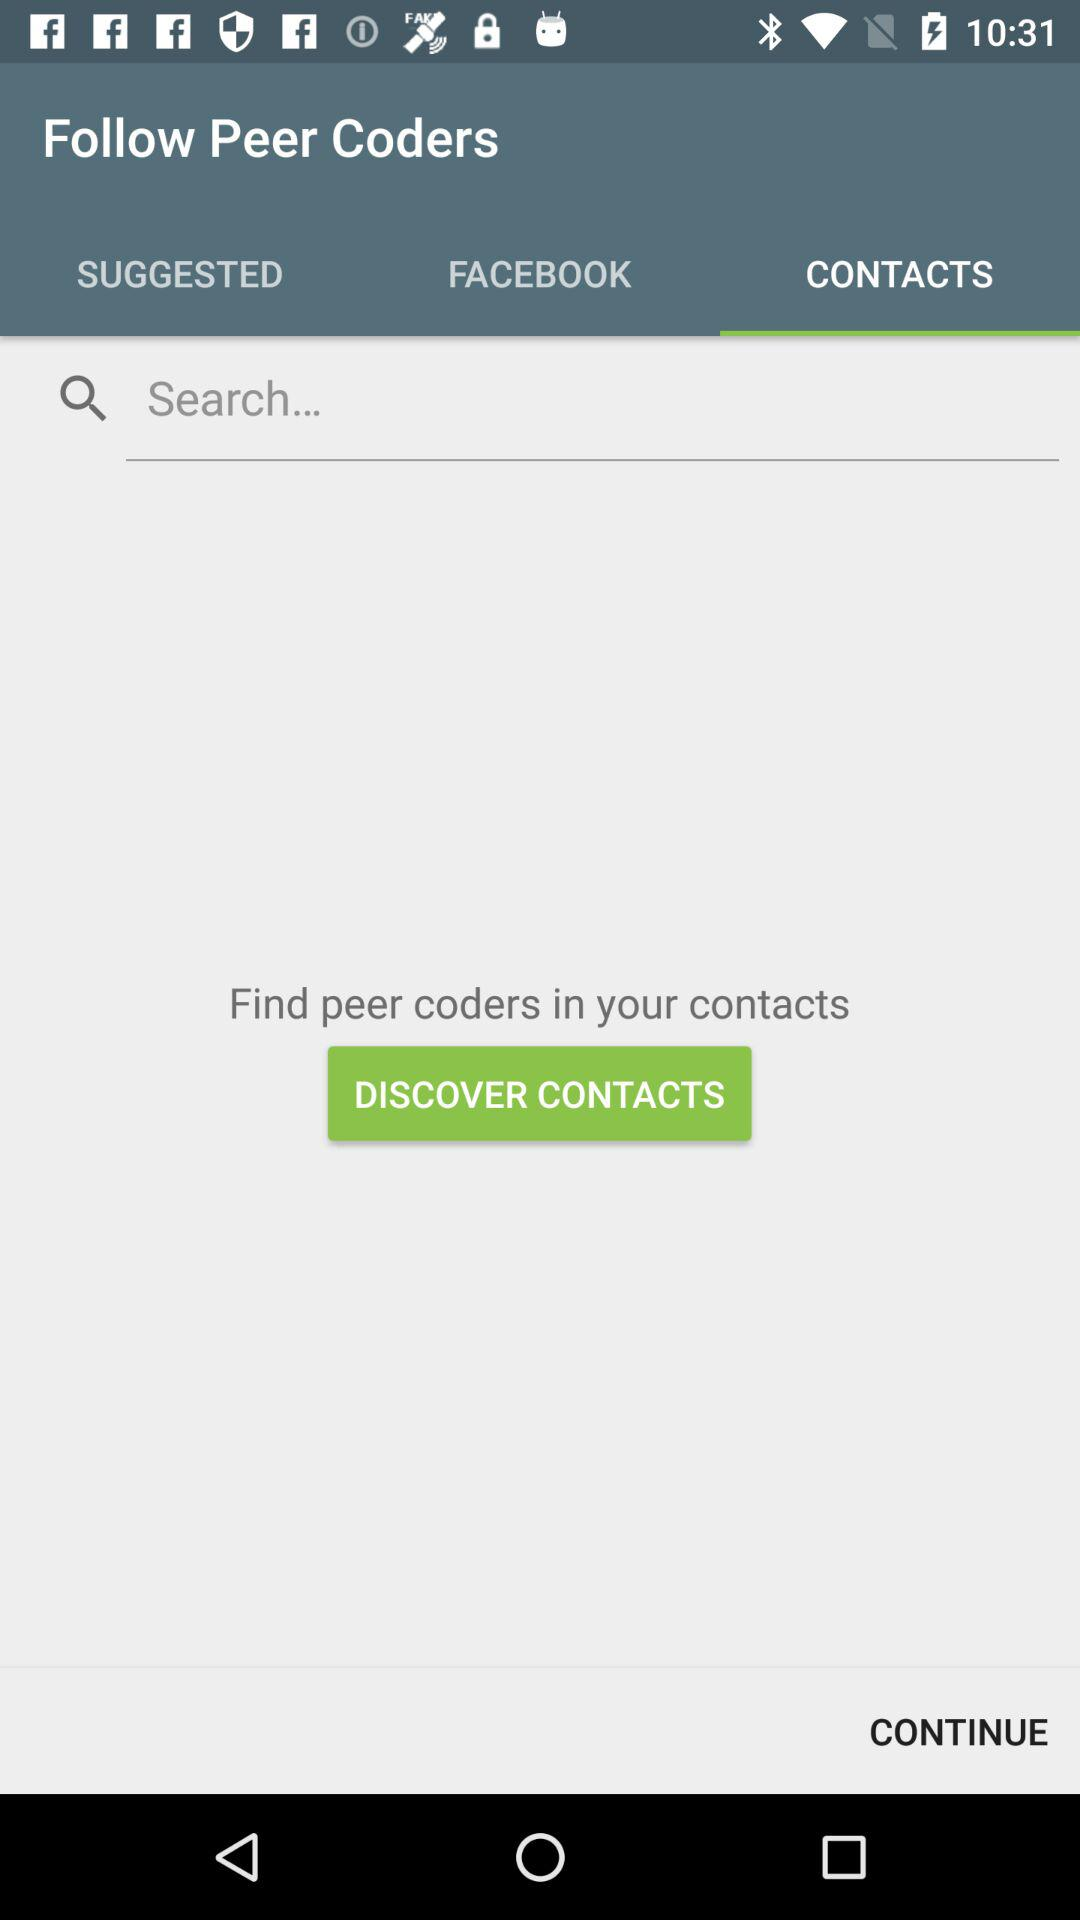What tab is selected? The selected tab is "CONTACTS". 